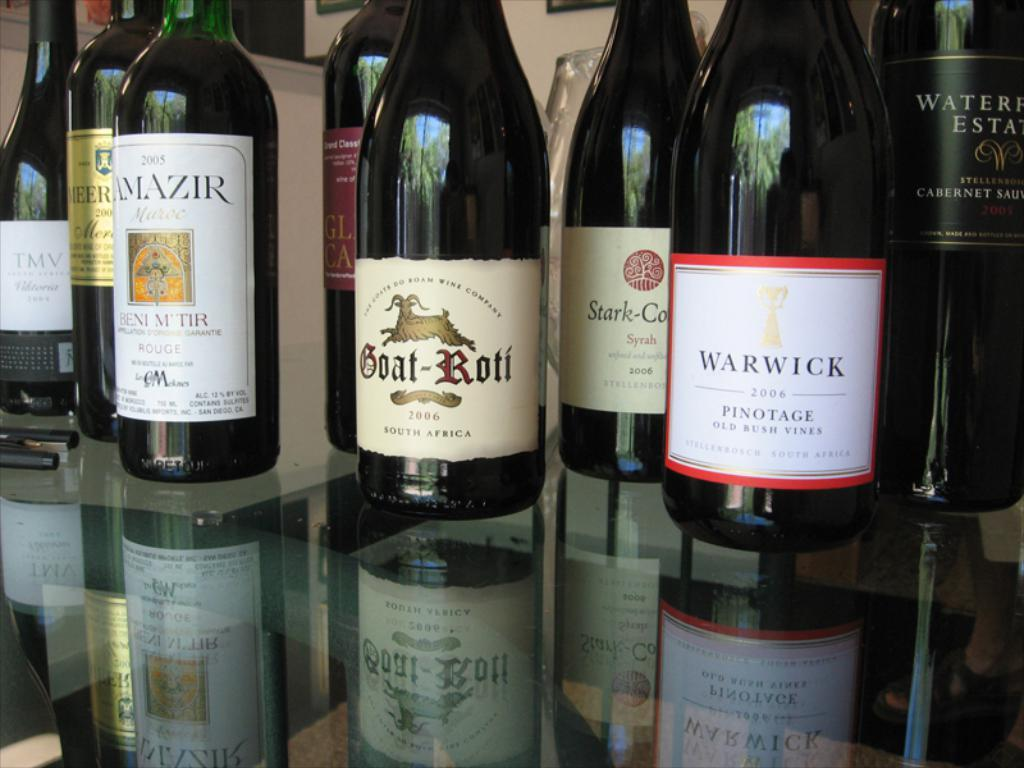<image>
Give a short and clear explanation of the subsequent image. Bottles of wine, including Warwick,are on a glass top. 